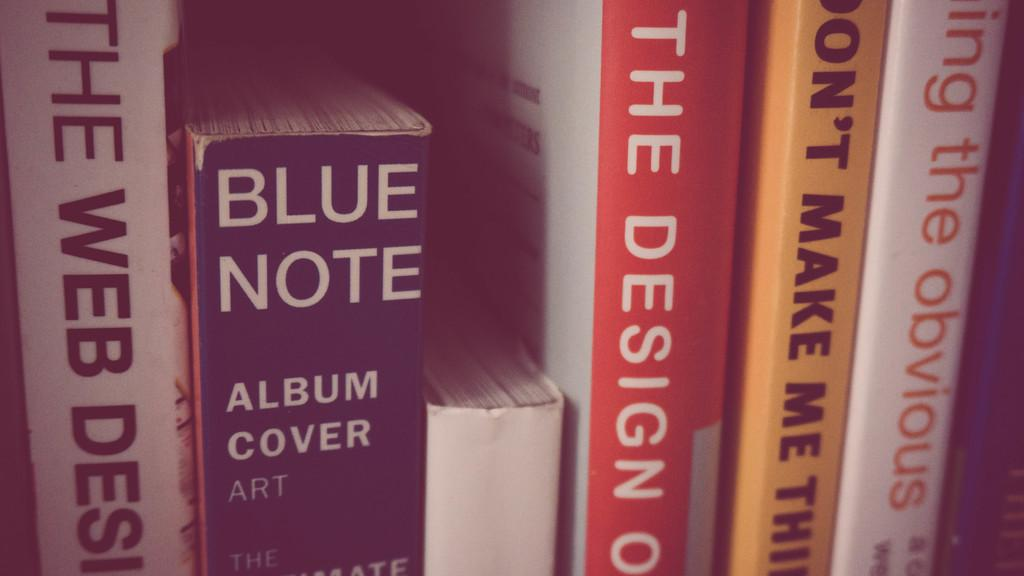<image>
Offer a succinct explanation of the picture presented. Blue Note is a very thick book about album cover art. 